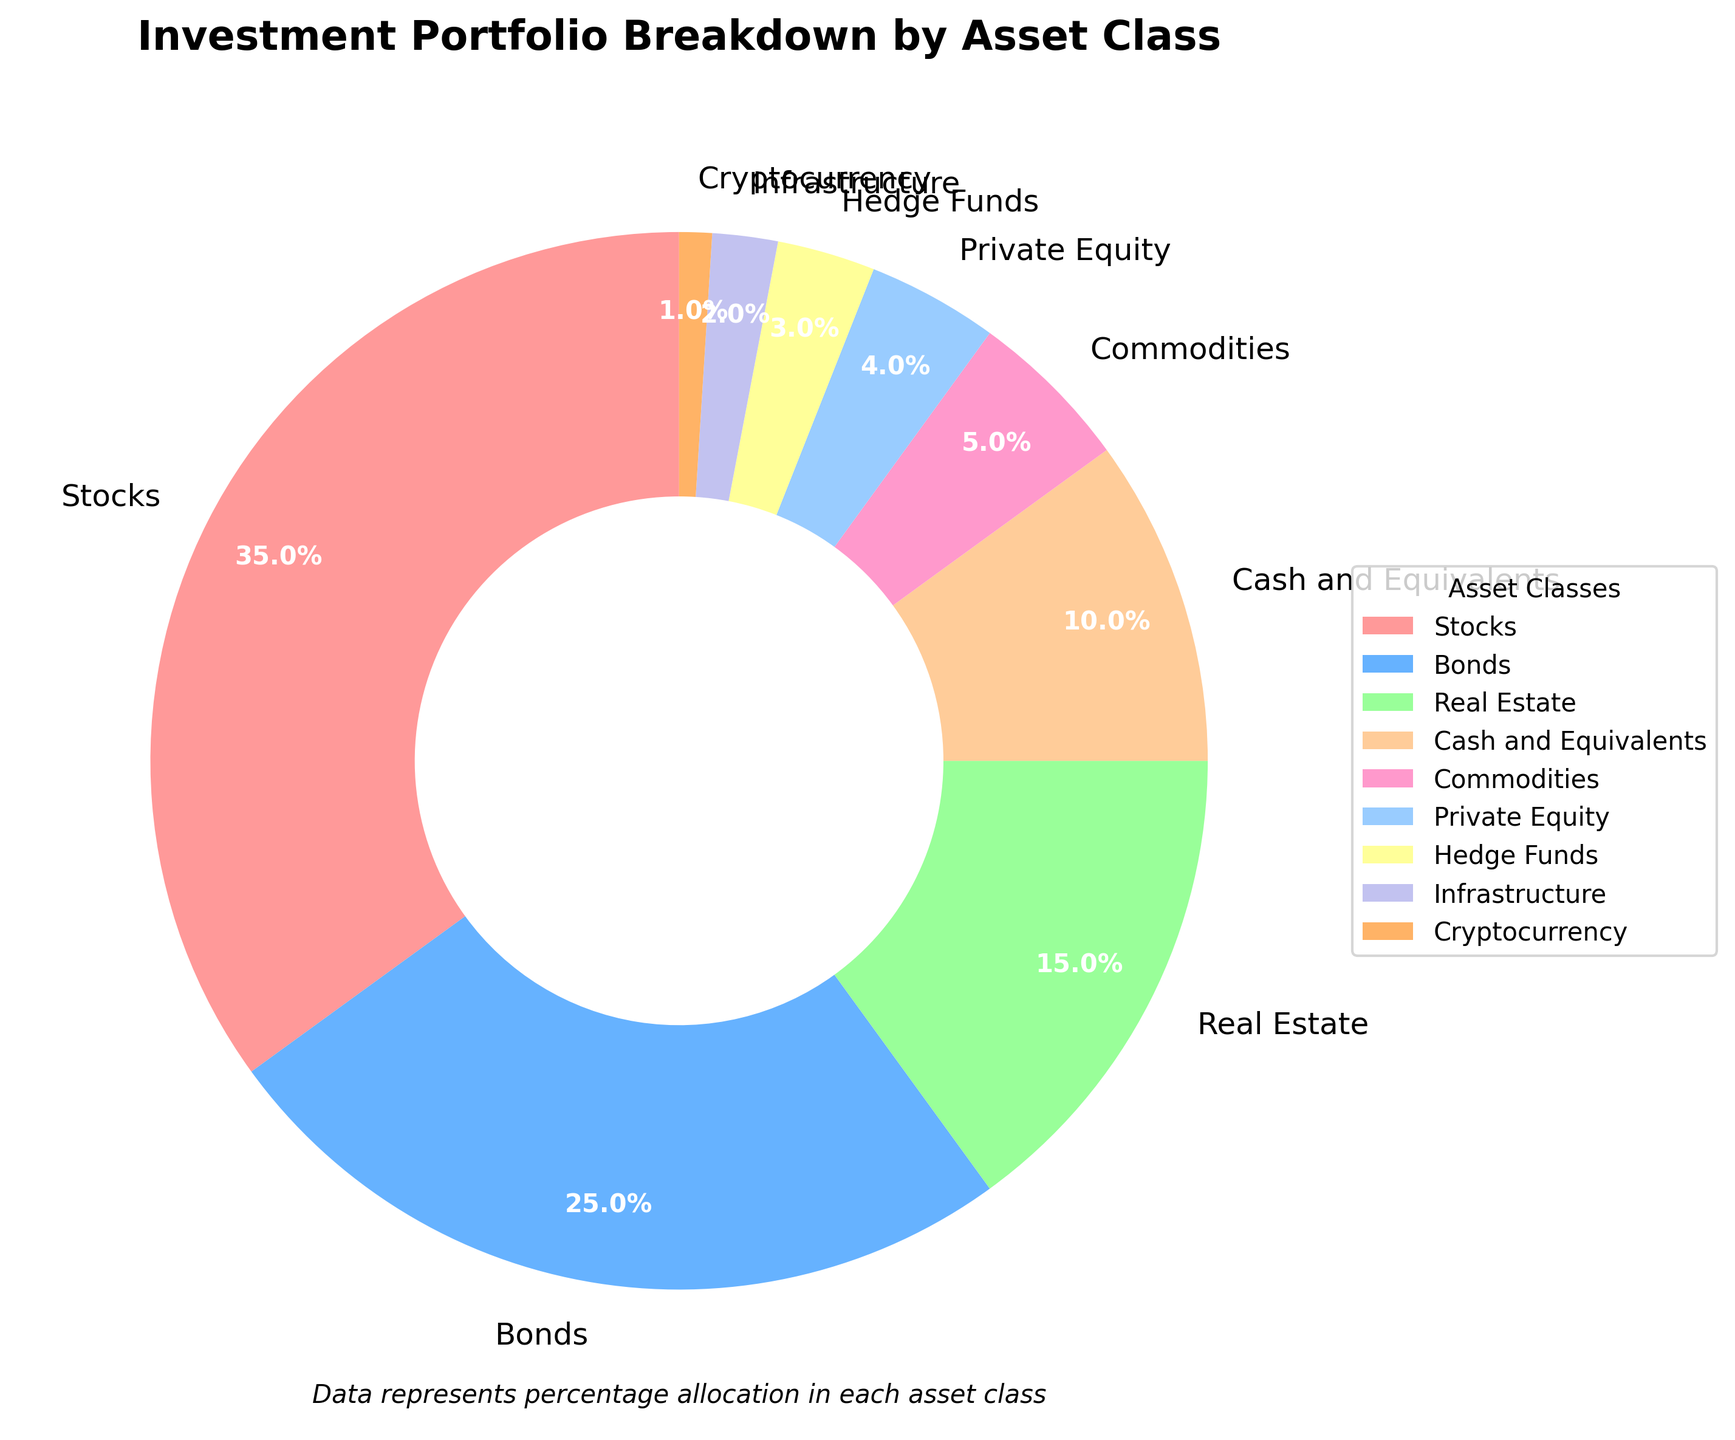Which asset class has the highest percentage in the breakdown? The asset class with the highest percentage in the breakdown is the one with the largest slice in the pie chart. By looking at the chart, we can see that "Stocks" has the largest slice.
Answer: Stocks Which asset class has the smallest percentage in the portfolio? The asset class with the smallest percentage is the one with the smallest slice in the pie chart. By observing the chart, we can see that "Cryptocurrency" has the smallest slice.
Answer: Cryptocurrency What is the combined percentage of Bonds and Real Estate? To find the combined percentage, add the percentage values for Bonds and Real Estate. Bonds is 25% and Real Estate is 15%, so the combined percentage is \(25 + 15 = 40\%\).
Answer: 40% Is the percentage of Cash and Equivalents greater than Commodities? Compare the two percentage values in the pie chart. The percentage of Cash and Equivalents is 10%, while Commodities is 5%. Since 10% is greater than 5%, the percentage of Cash and Equivalents is greater.
Answer: Yes What fraction of the investment portfolio is in Private Equity, Hedge Funds, and Infrastructure combined? To find the fraction of the portfolio for these three asset classes combined, add their percentages: \(Private Equity (4\%) + Hedge Funds (3\%) + Infrastructure (2\%) = 9\%\), then convert this into a fraction of the entire portfolio which is out of 100%, so \(9/100 = 0.09\).
Answer: 0.09 What is the difference in percentage between the largest and smallest asset classes? Identify the largest and smallest asset classes, which are "Stocks" and "Cryptocurrency" respectively. The difference in their percentages is \(35 - 1 = 34\%\).
Answer: 34% How many asset classes have a percentage greater than 10%? Count the number of asset classes where the percentage is greater than 10%. By checking the chart: Stocks (35%), Bonds (25%), Real Estate (15%) are greater than 10%.
Answer: 3 Is the total percentage of alternative investments (Commodities, Private Equity, Hedge Funds, Infrastructure, Cryptocurrency) less than that of Bonds? Calculate the total percentage of the listed alternative investments: \(5 + 4 + 3 + 2 + 1 = 15\%\). Compare this with Bonds, which is 25%. Since 15% is less than 25%, the total percentage of these alternative investments is less.
Answer: Yes 